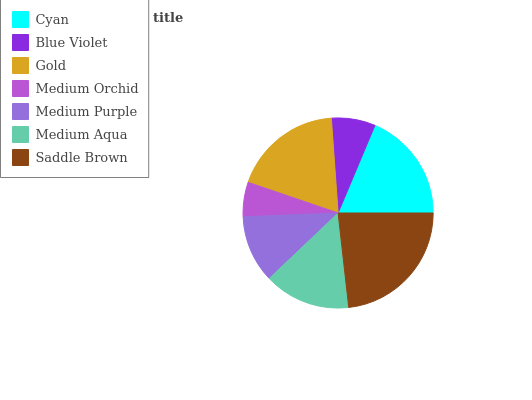Is Medium Orchid the minimum?
Answer yes or no. Yes. Is Saddle Brown the maximum?
Answer yes or no. Yes. Is Blue Violet the minimum?
Answer yes or no. No. Is Blue Violet the maximum?
Answer yes or no. No. Is Cyan greater than Blue Violet?
Answer yes or no. Yes. Is Blue Violet less than Cyan?
Answer yes or no. Yes. Is Blue Violet greater than Cyan?
Answer yes or no. No. Is Cyan less than Blue Violet?
Answer yes or no. No. Is Medium Aqua the high median?
Answer yes or no. Yes. Is Medium Aqua the low median?
Answer yes or no. Yes. Is Blue Violet the high median?
Answer yes or no. No. Is Medium Orchid the low median?
Answer yes or no. No. 